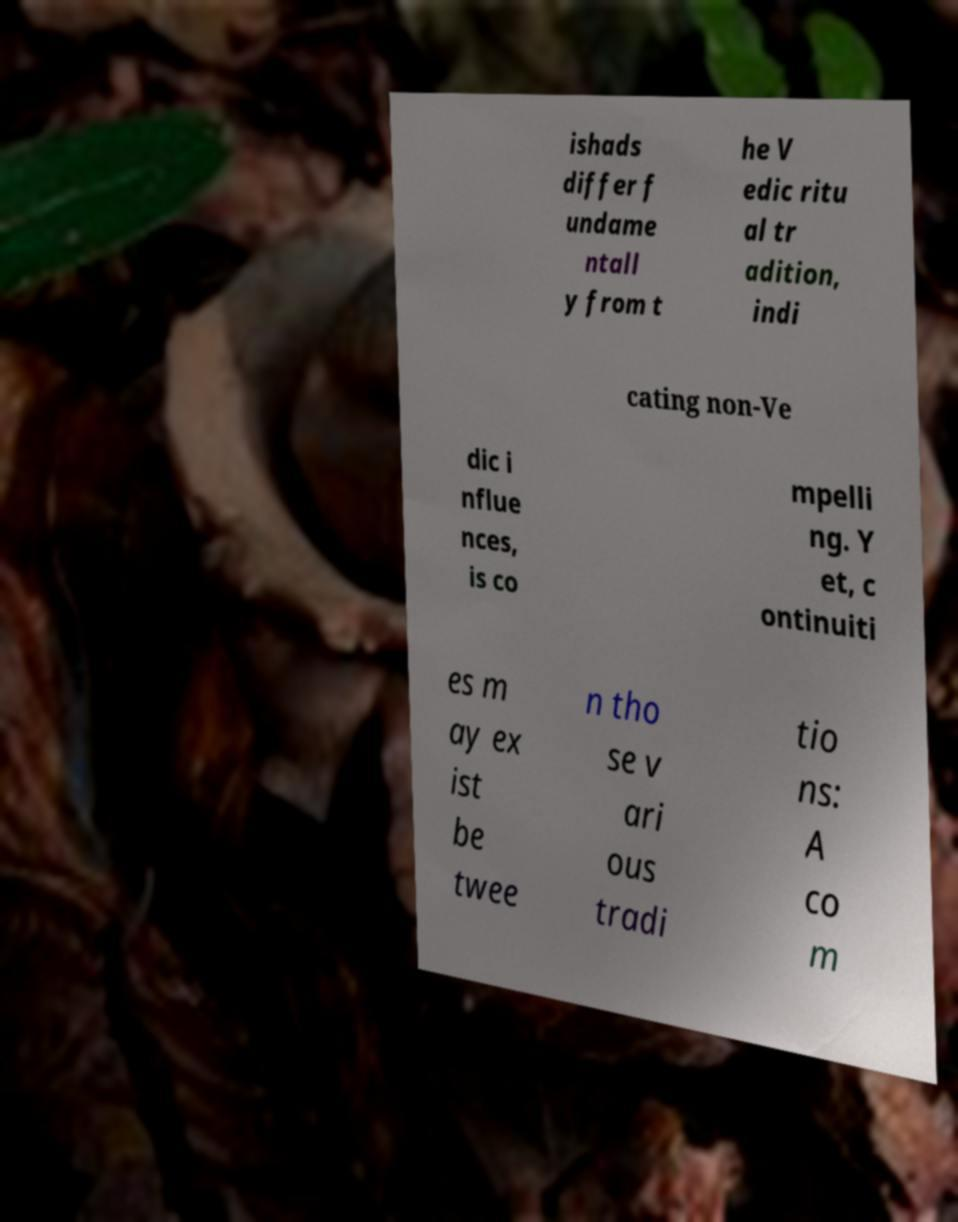Could you extract and type out the text from this image? ishads differ f undame ntall y from t he V edic ritu al tr adition, indi cating non-Ve dic i nflue nces, is co mpelli ng. Y et, c ontinuiti es m ay ex ist be twee n tho se v ari ous tradi tio ns: A co m 